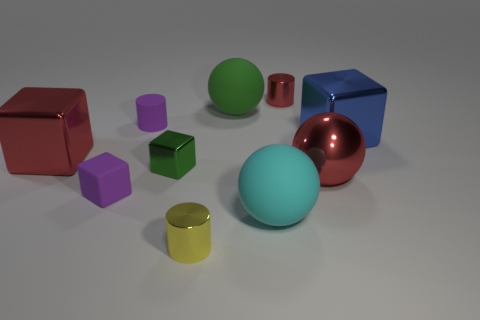How might the size of the objects relate to each other? The objects vary in size, offering a comparative perspective. The largest item is the cyan sphere, while there are also mid-sized shapes like the red cube, and smaller pieces like the green cube and the purple cube, forming a diverse scale that could be used for size recognition exercises or graphical composition. 